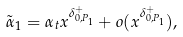Convert formula to latex. <formula><loc_0><loc_0><loc_500><loc_500>\tilde { \alpha } _ { 1 } = \alpha _ { t } x ^ { \delta _ { 0 , P _ { 1 } } ^ { + } } + o ( x ^ { \delta _ { 0 , P _ { 1 } } ^ { + } } ) ,</formula> 